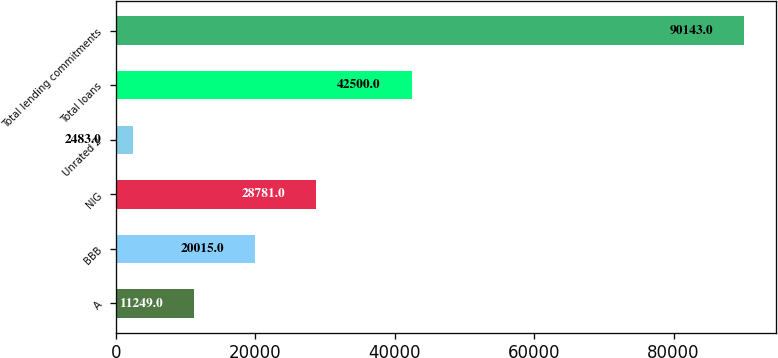Convert chart. <chart><loc_0><loc_0><loc_500><loc_500><bar_chart><fcel>A<fcel>BBB<fcel>NIG<fcel>Unrated 2<fcel>Total loans<fcel>Total lending commitments<nl><fcel>11249<fcel>20015<fcel>28781<fcel>2483<fcel>42500<fcel>90143<nl></chart> 